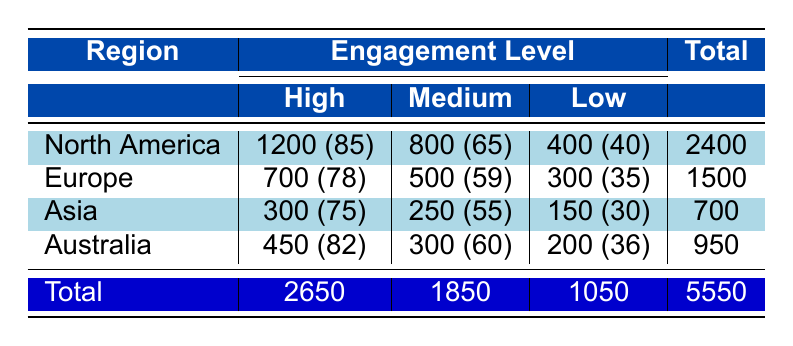What is the total number of members in North America? The table states that North America has three engagement levels with the following members: High (1200), Medium (800), and Low (400). To find the total, we add these numbers together: 1200 + 800 + 400 = 2400.
Answer: 2400 Which region has the highest number of members at a medium engagement level? Looking at the Medium engagement level, we can see the following members: North America (800), Europe (500), Asia (250), and Australia (300). North America has the highest value with 800 members.
Answer: North America What is the average engagement score for Europe? Europe has three engagement levels: High (78), Medium (59), and Low (35). To find the average score, we first sum these scores: 78 + 59 + 35 = 172. Then we divide by the number of levels (3): 172 / 3 = approximately 57.33.
Answer: Approximately 57.33 How many total members does Australia have compared to Asia? Australia has 950 members (High: 450, Medium: 300, Low: 200) and Asia has 700 members (High: 300, Medium: 250, Low: 150). To compare, we see 950 (Australia) > 700 (Asia).
Answer: Australia has more members Is it true that Europe has a higher average engagement score at the high level than Asia? Europe has an average engagement score of 78 at the High level, while Asia has 75. Since 78 > 75, it is true that Europe has a higher score.
Answer: Yes 